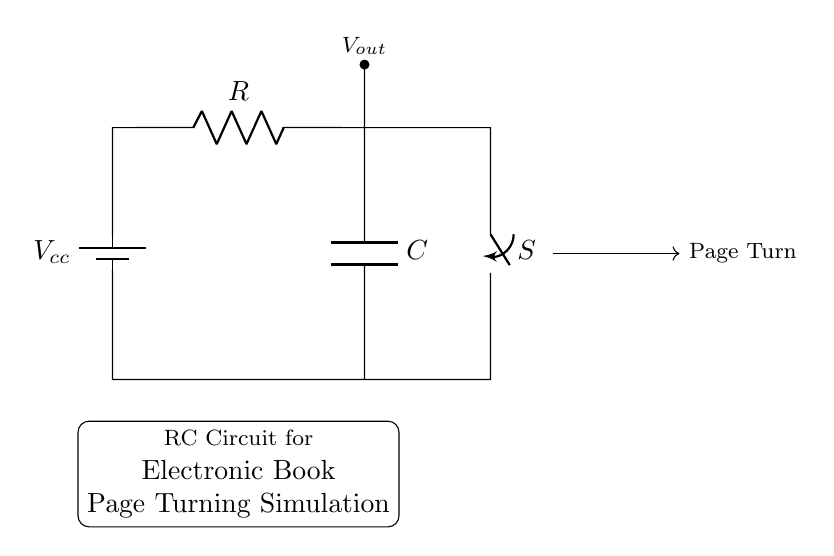What is the type of the circuit shown? The circuit is an RC circuit, which consists of a resistor and a capacitor connected in series. This is evident from the presence of both components labeled as R and C in the diagram.
Answer: RC circuit What does the switch in the diagram represent? The switch represents a control mechanism that can open or close the circuit, affecting the charging and discharging of the capacitor. This is indicated by the label S and its connection in the diagram.
Answer: Control mechanism What is the function of the capacitor in this RC circuit? The capacitor stores electrical energy and releases it gradually, affecting the timing for the page turning simulation. This is a key function of capacitors in RC circuits, implying time-dependent behaviors.
Answer: Store energy What is the role of the resistor in this circuit? The resistor limits the current flowing through the circuit, which controls the rate at which the capacitor charges and discharges. The impact of the resistor can be observed in the voltage and current relationships in the circuit.
Answer: Limit current What can be inferred about the output voltage when the switch is closed? When the switch is closed, the circuit completes, allowing the capacitor to charge to a voltage determined by the source voltage and resistance. This reflects the behavior dictated by the time constant of the RC circuit.
Answer: Charges to Vcc How does changing the resistance value affect the time constant of the circuit? Increasing resistance will increase the time constant, meaning the capacitor will take longer to charge and discharge. The time constant is specifically defined as the product of R and C, indicating a direct relationship between them.
Answer: Increases time constant 